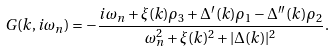Convert formula to latex. <formula><loc_0><loc_0><loc_500><loc_500>G ( k , i \omega _ { n } ) = - \frac { i \omega _ { n } + \xi ( k ) \rho _ { 3 } + \Delta ^ { \prime } ( k ) \rho _ { 1 } - \Delta ^ { \prime \prime } ( k ) \rho _ { 2 } } { \omega _ { n } ^ { 2 } + \xi ( k ) ^ { 2 } + | \Delta ( k ) | ^ { 2 } } .</formula> 